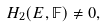<formula> <loc_0><loc_0><loc_500><loc_500>H _ { 2 } ( E , { \mathbb { F } } ) \neq 0 ,</formula> 